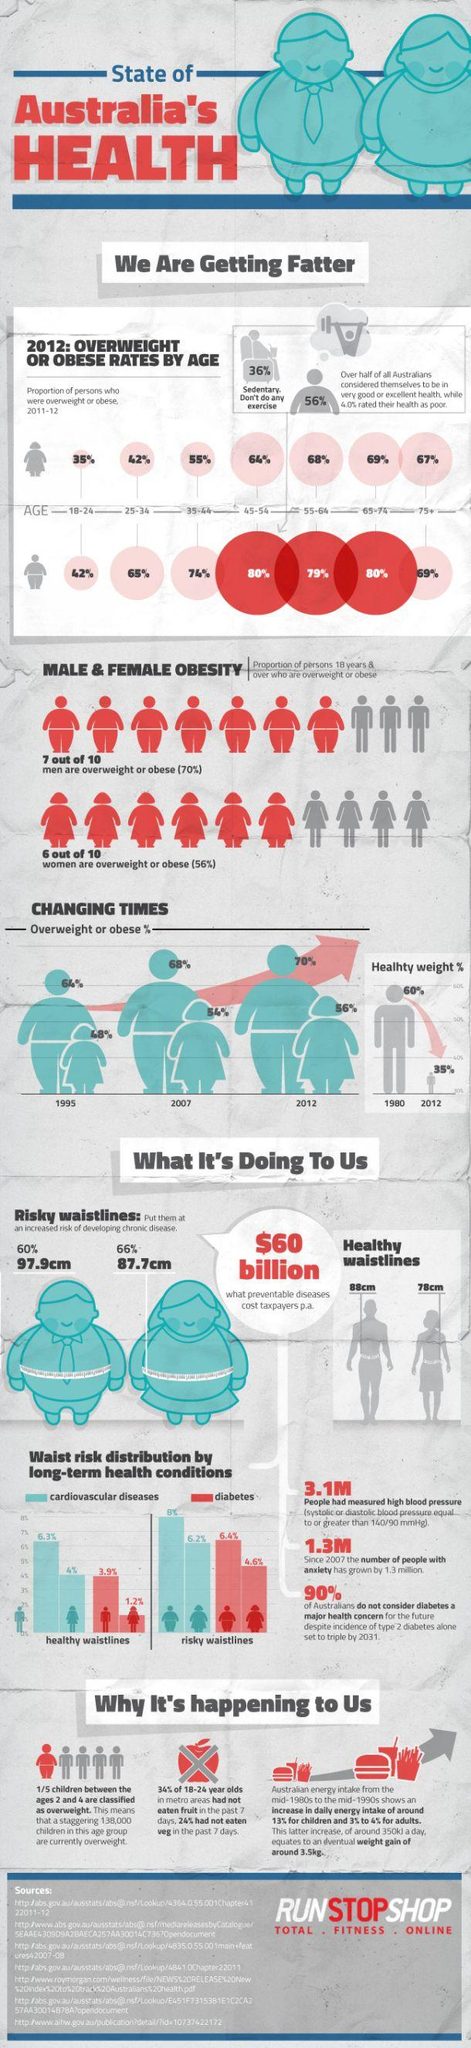Highlight a few significant elements in this photo. The recommended healthy waistline for women is 78 centimeters. The recommended healthy waistline for men is 88 cm. The distribution of waist size can potentially indicate the presence of two types of long-term health conditions. The prevalence of obesity in the age groups 45-54 and 65-74 is approximately 80%. The study found that men with diabetes who had healthy waistlines had a lower percentage difference compared to men with diabetes who had risky waistlines, at 2.5%. 